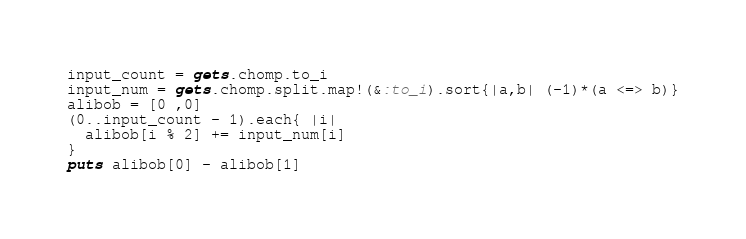Convert code to text. <code><loc_0><loc_0><loc_500><loc_500><_Ruby_>input_count = gets.chomp.to_i
input_num = gets.chomp.split.map!(&:to_i).sort{|a,b| (-1)*(a <=> b)}
alibob = [0 ,0]
(0..input_count - 1).each{ |i|
  alibob[i % 2] += input_num[i]
}
puts alibob[0] - alibob[1]</code> 